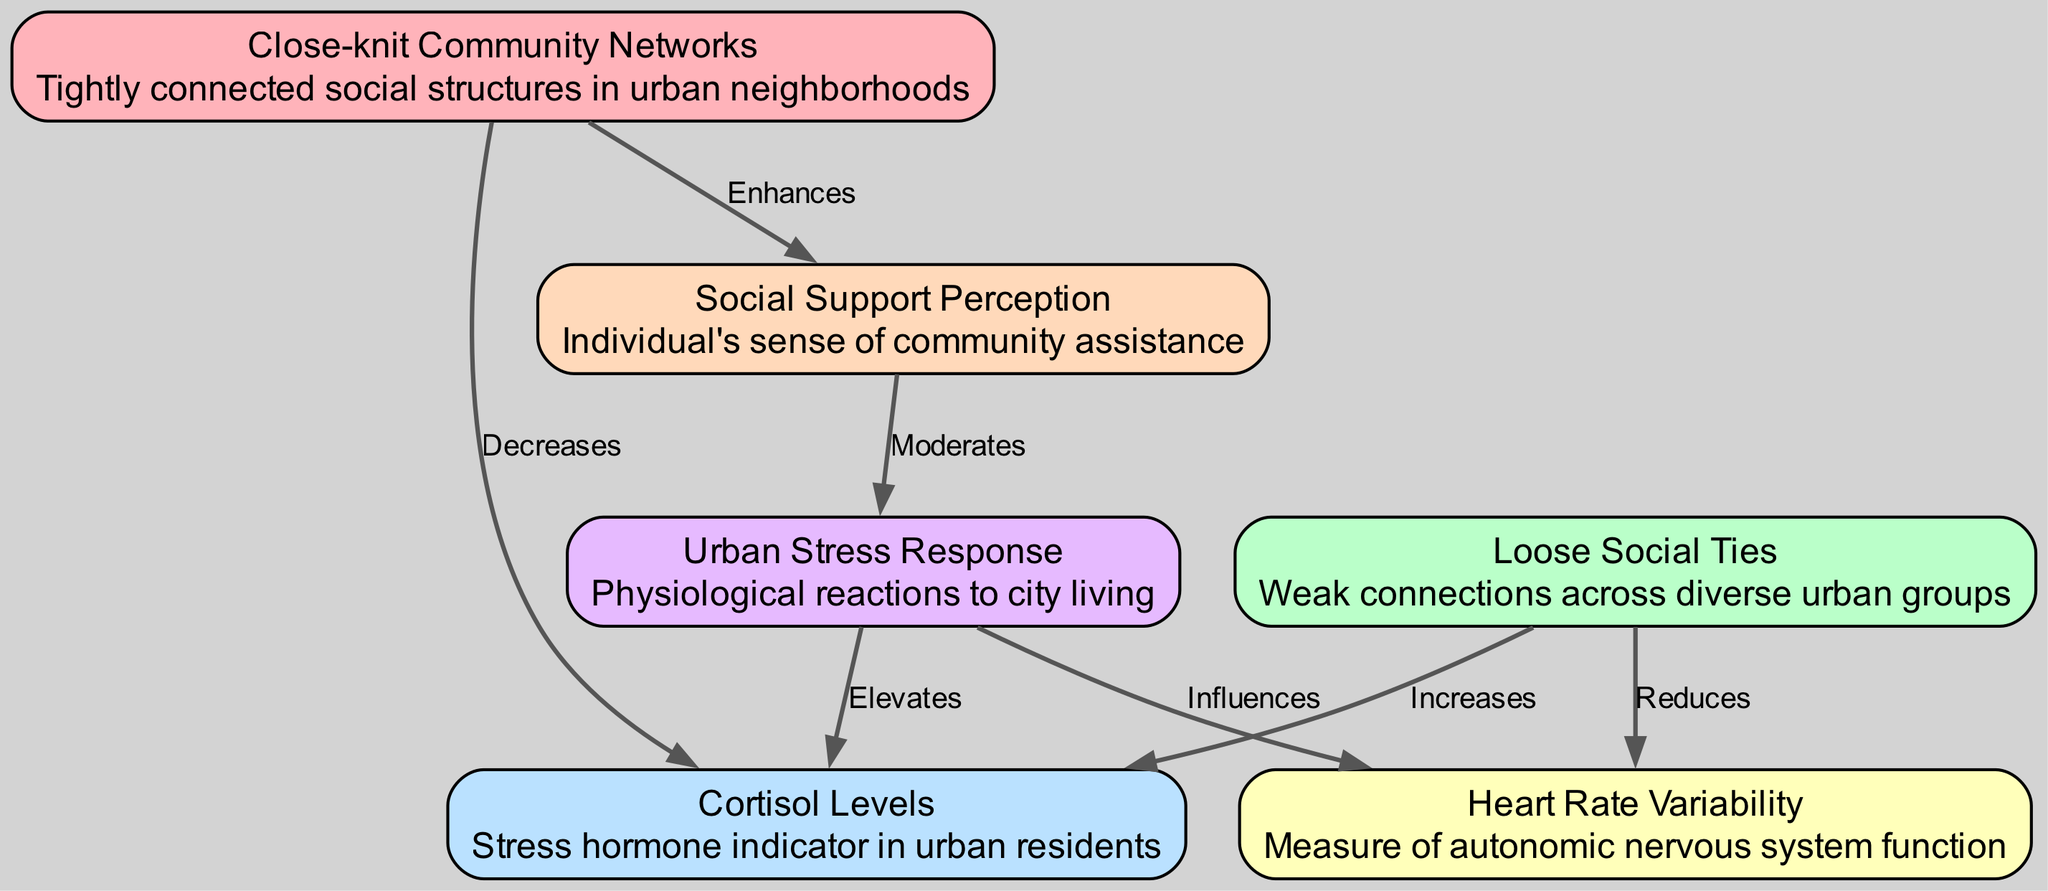What are the two types of community networks shown? The diagram displays two community network types: "Close-knit Community Networks" and "Loose Social Ties". This information is directly available in the node descriptions labeled in the diagram.
Answer: Close-knit Community Networks, Loose Social Ties How many nodes are in the diagram? The diagram contains 6 nodes, as detailed in the initial data where each unique type is listed.
Answer: 6 What effect does "Close-knit Community Networks" have on "Cortisol Levels"? According to the diagram, "Close-knit Community Networks" decreases "Cortisol Levels". This relationship is indicated by the directed edge labeled "Decreases" between these two nodes.
Answer: Decreases What is the relationship between "Loose Social Ties" and "Heart Rate Variability"? The diagram shows that "Loose Social Ties" reduces "Heart Rate Variability". This can be deduced from the directed edge between the respective nodes, labeled "Reduces".
Answer: Reduces Which factor moderates the "Urban Stress Response"? "Social Support Perception" is indicated as moderating the "Urban Stress Response". The directed edge from "Social Support Perception" to "Urban Stress Response" is labeled "Moderates", confirming this influence.
Answer: Social Support Perception What is the physiological reaction pattern indicated by the diagram when urban residents experience high stress? The diagram shows that high "Urban Stress Response" elevates "Cortisol Levels" and influences "Heart Rate Variability". This pattern is evident through the directed edges from "Urban Stress Response" to both of these physiological measurements.
Answer: Elevates/Cortisol Levels, Influences/Heart Rate Variability Which network type is shown to enhance the perception of social support? "Close-knit Community Networks" is the type that enhances the perception of social support, as indicated by the directed edge labeled "Enhances" from this node to "Social Support Perception".
Answer: Close-knit Community Networks What effect does "Loose Social Ties" have on "Cortisol Levels"? The diagram indicates that "Loose Social Ties" increases "Cortisol Levels", which is shown by the directed edge labeled "Increases" originating from "Loose Social Ties" and pointing to "Cortisol Levels".
Answer: Increases 